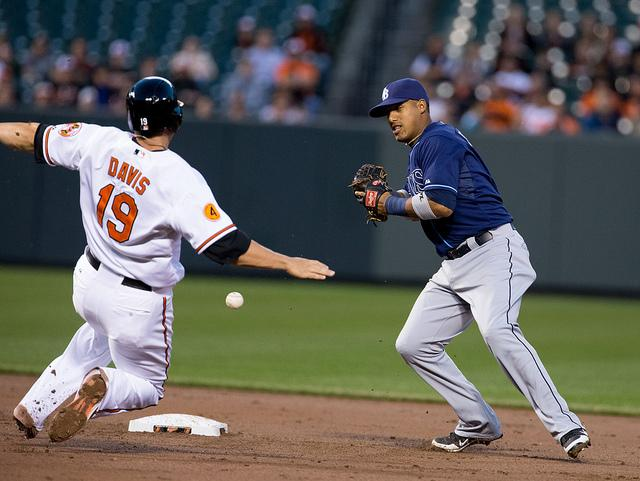What is 19 trying to do? slide 